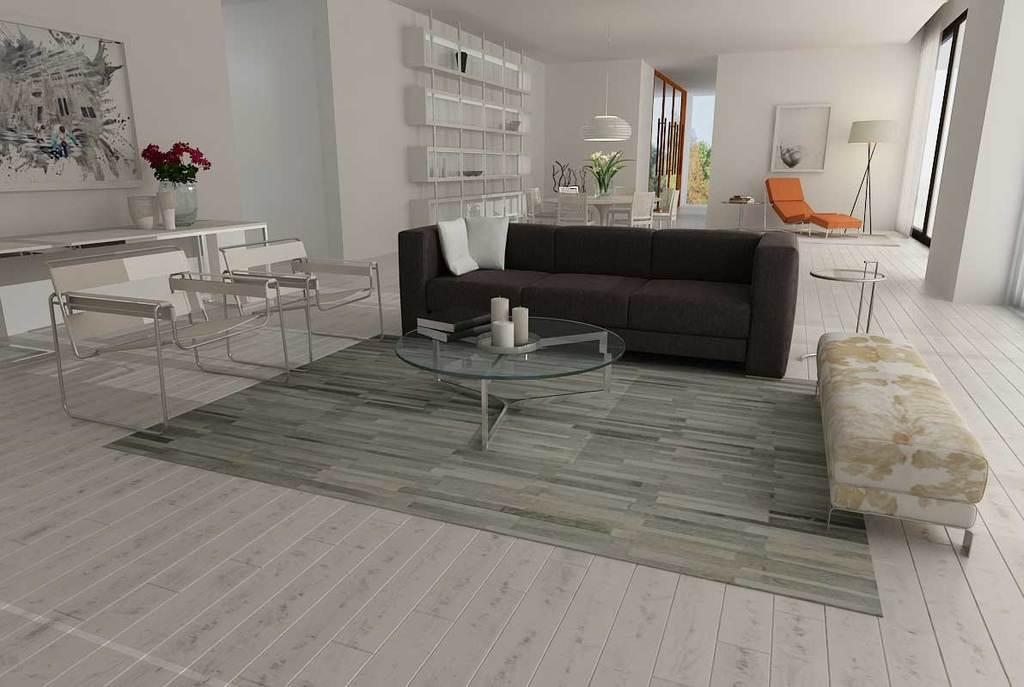What type of furniture is present in the image? There is a sofa and chairs in the image. How many tables are visible in the image? There are two tables in the image. What can be seen in the background of the image? There is a wall, a photo frame, and a flower vase in the background of the image. What type of range can be seen in the image? There is no range present in the image. Can you describe the pear that is on the table in the image? There is no pear present in the image. 